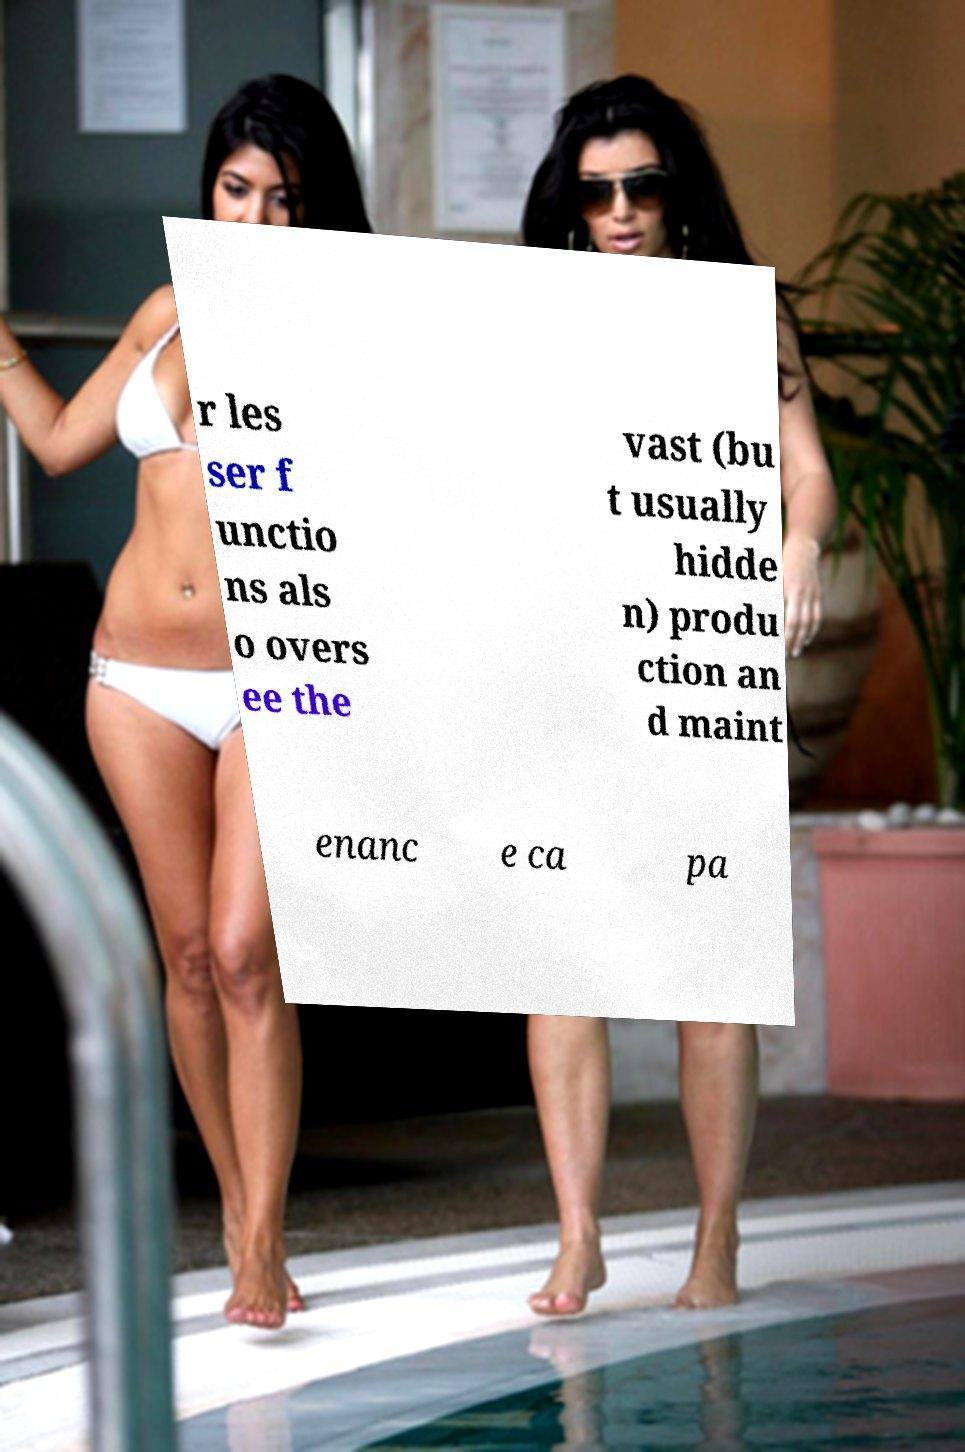I need the written content from this picture converted into text. Can you do that? r les ser f unctio ns als o overs ee the vast (bu t usually hidde n) produ ction an d maint enanc e ca pa 